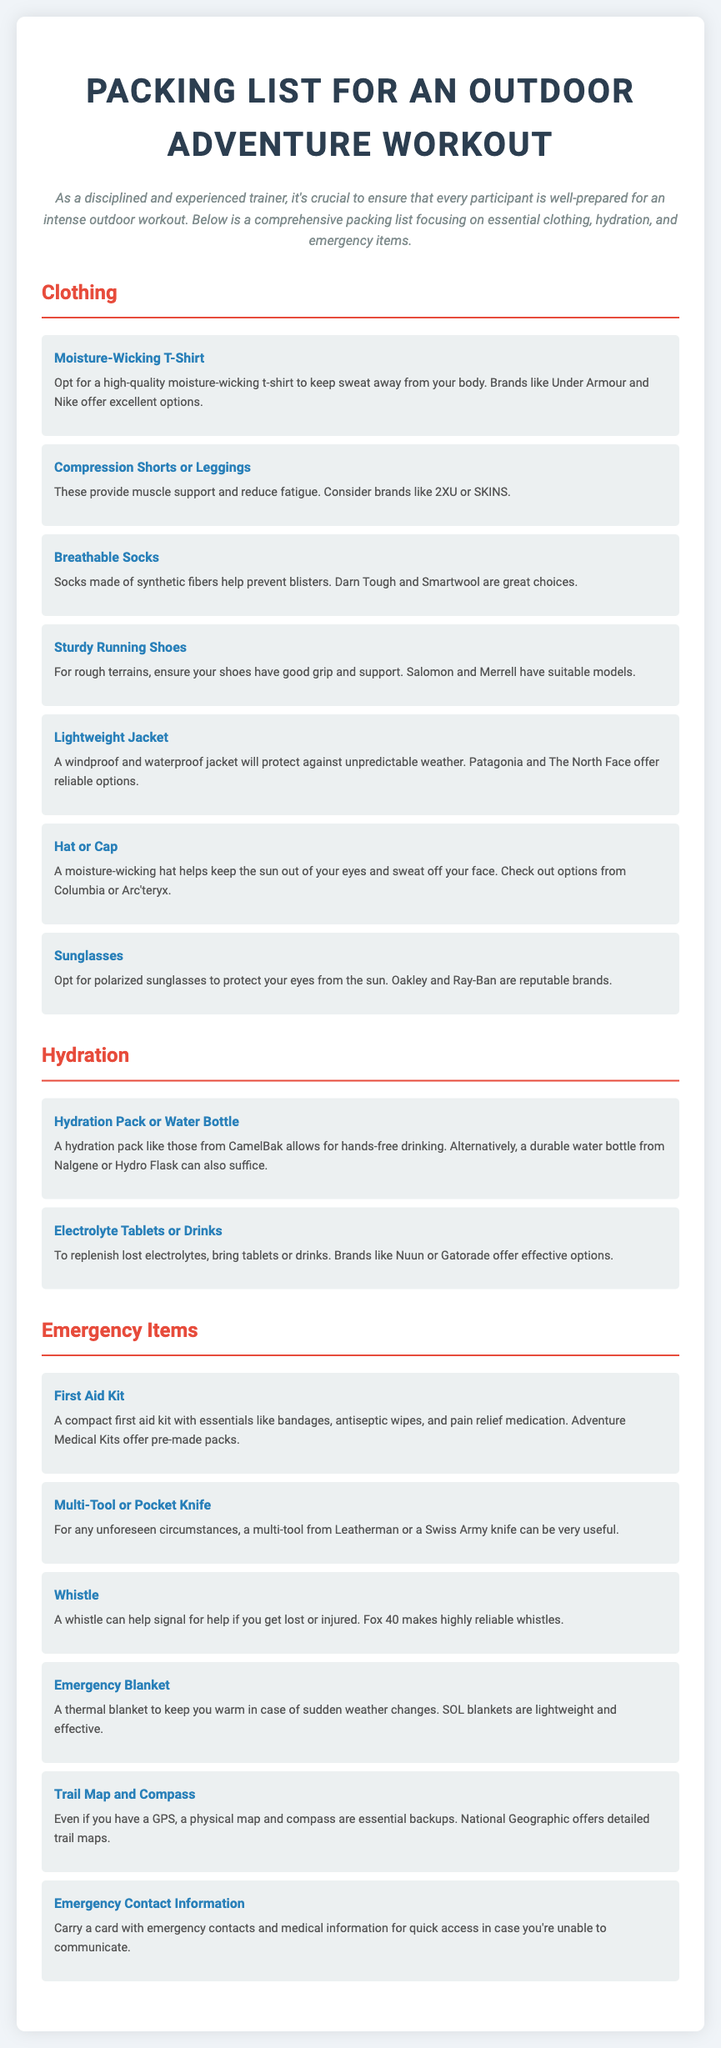What should you pack for hydration? The hydration section lists two items: a hydration pack or water bottle and electrolyte tablets or drinks.
Answer: Hydration pack or water bottle, electrolyte tablets or drinks What is a recommended brand for sturdy running shoes? The document mentions two brands for sturdy running shoes: Salomon and Merrell.
Answer: Salomon, Merrell What is one item you should carry for emergencies? The emergency items section includes multiple options, one of which is a first aid kit.
Answer: First aid kit Which type of clothing is suggested for moisture management? The document specifies a moisture-wicking t-shirt as essential clothing for keeping sweat away.
Answer: Moisture-Wicking T-Shirt What is the purpose of a whistle according to the document? The document states that a whistle can help signal for help if you get lost or injured.
Answer: Signal for help What item provides thermal protection from sudden weather changes? The document indicates that an emergency blanket can keep you warm in case of sudden weather changes.
Answer: Emergency Blanket List one brand mentioned for breathable socks. The document lists Darn Tough and Smartwool as recommended brands for breathable socks.
Answer: Darn Tough, Smartwool What is one feature to look for in a lightweight jacket? A windproof and waterproof jacket is mentioned as key features to protect against unpredictable weather.
Answer: Windproof and waterproof Which item can help you signal for help? The document mentions that a whistle can help you signal for help.
Answer: Whistle 